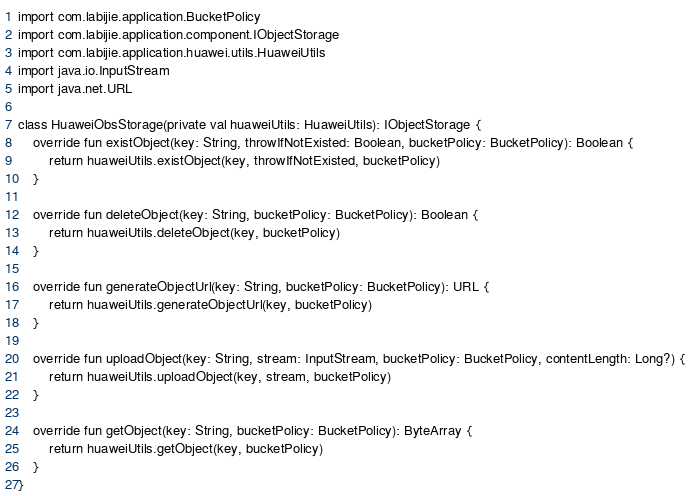Convert code to text. <code><loc_0><loc_0><loc_500><loc_500><_Kotlin_>import com.labijie.application.BucketPolicy
import com.labijie.application.component.IObjectStorage
import com.labijie.application.huawei.utils.HuaweiUtils
import java.io.InputStream
import java.net.URL

class HuaweiObsStorage(private val huaweiUtils: HuaweiUtils): IObjectStorage {
    override fun existObject(key: String, throwIfNotExisted: Boolean, bucketPolicy: BucketPolicy): Boolean {
        return huaweiUtils.existObject(key, throwIfNotExisted, bucketPolicy)
    }

    override fun deleteObject(key: String, bucketPolicy: BucketPolicy): Boolean {
        return huaweiUtils.deleteObject(key, bucketPolicy)
    }

    override fun generateObjectUrl(key: String, bucketPolicy: BucketPolicy): URL {
        return huaweiUtils.generateObjectUrl(key, bucketPolicy)
    }

    override fun uploadObject(key: String, stream: InputStream, bucketPolicy: BucketPolicy, contentLength: Long?) {
        return huaweiUtils.uploadObject(key, stream, bucketPolicy)
    }

    override fun getObject(key: String, bucketPolicy: BucketPolicy): ByteArray {
        return huaweiUtils.getObject(key, bucketPolicy)
    }
}</code> 